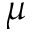Convert formula to latex. <formula><loc_0><loc_0><loc_500><loc_500>\mu</formula> 